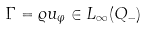Convert formula to latex. <formula><loc_0><loc_0><loc_500><loc_500>\Gamma = \varrho u _ { \varphi } \in L _ { \infty } ( Q _ { - } )</formula> 